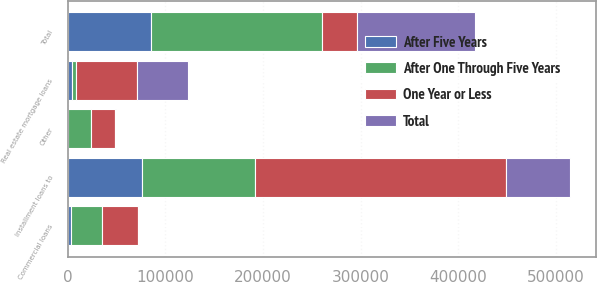<chart> <loc_0><loc_0><loc_500><loc_500><stacked_bar_chart><ecel><fcel>Commercial loans<fcel>Real estate mortgage loans<fcel>Installment loans to<fcel>Other<fcel>Total<nl><fcel>After One Through Five Years<fcel>31516<fcel>4050<fcel>116027<fcel>23512<fcel>175105<nl><fcel>After Five Years<fcel>3866<fcel>4965<fcel>75853<fcel>355<fcel>85039<nl><fcel>Total<fcel>1089<fcel>52673<fcel>65580<fcel>849<fcel>120191<nl><fcel>One Year or Less<fcel>36471<fcel>61688<fcel>257460<fcel>24716<fcel>36471<nl></chart> 